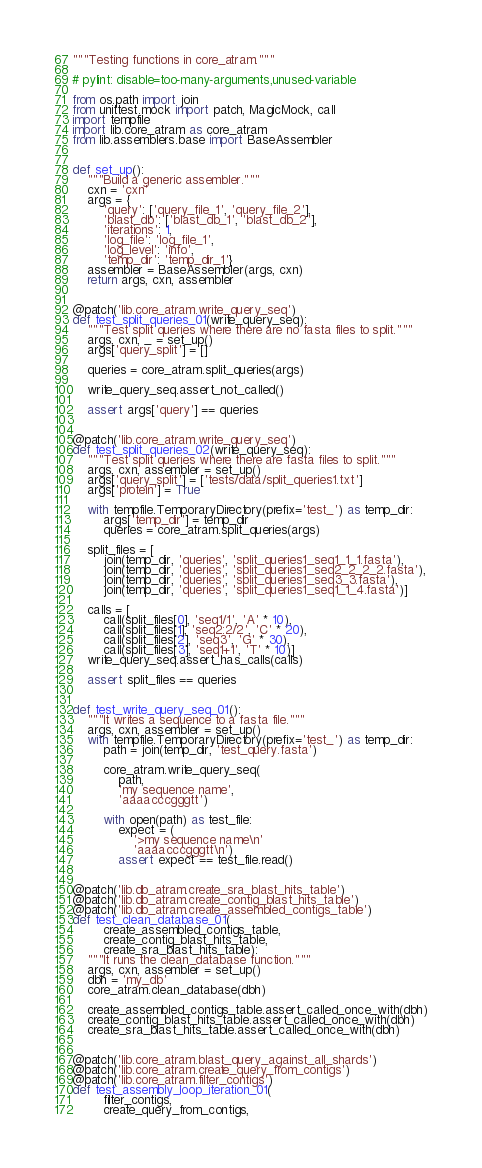<code> <loc_0><loc_0><loc_500><loc_500><_Python_>"""Testing functions in core_atram."""

# pylint: disable=too-many-arguments,unused-variable

from os.path import join
from unittest.mock import patch, MagicMock, call
import tempfile
import lib.core_atram as core_atram
from lib.assemblers.base import BaseAssembler


def set_up():
    """Build a generic assembler."""
    cxn = 'cxn'
    args = {
        'query': ['query_file_1', 'query_file_2'],
        'blast_db': ['blast_db_1', 'blast_db_2'],
        'iterations': 1,
        'log_file': 'log_file_1',
        'log_level': 'info',
        'temp_dir': 'temp_dir_1'}
    assembler = BaseAssembler(args, cxn)
    return args, cxn, assembler


@patch('lib.core_atram.write_query_seq')
def test_split_queries_01(write_query_seq):
    """Test split queries where there are no fasta files to split."""
    args, cxn, _ = set_up()
    args['query_split'] = []

    queries = core_atram.split_queries(args)

    write_query_seq.assert_not_called()

    assert args['query'] == queries


@patch('lib.core_atram.write_query_seq')
def test_split_queries_02(write_query_seq):
    """Test split queries where there are fasta files to split."""
    args, cxn, assembler = set_up()
    args['query_split'] = ['tests/data/split_queries1.txt']
    args['protein'] = True

    with tempfile.TemporaryDirectory(prefix='test_') as temp_dir:
        args['temp_dir'] = temp_dir
        queries = core_atram.split_queries(args)

    split_files = [
        join(temp_dir, 'queries', 'split_queries1_seq1_1_1.fasta'),
        join(temp_dir, 'queries', 'split_queries1_seq2_2_2_2.fasta'),
        join(temp_dir, 'queries', 'split_queries1_seq3_3.fasta'),
        join(temp_dir, 'queries', 'split_queries1_seq1_1_4.fasta')]

    calls = [
        call(split_files[0], 'seq1/1', 'A' * 10),
        call(split_files[1], 'seq2:2/2', 'C' * 20),
        call(split_files[2], 'seq3', 'G' * 30),
        call(split_files[3], 'seq1+1', 'T' * 10)]
    write_query_seq.assert_has_calls(calls)

    assert split_files == queries


def test_write_query_seq_01():
    """It writes a sequence to a fasta file."""
    args, cxn, assembler = set_up()
    with tempfile.TemporaryDirectory(prefix='test_') as temp_dir:
        path = join(temp_dir, 'test_query.fasta')

        core_atram.write_query_seq(
            path,
            'my sequence name',
            'aaaacccgggtt')

        with open(path) as test_file:
            expect = (
                '>my sequence name\n'
                'aaaacccgggtt\n')
            assert expect == test_file.read()


@patch('lib.db_atram.create_sra_blast_hits_table')
@patch('lib.db_atram.create_contig_blast_hits_table')
@patch('lib.db_atram.create_assembled_contigs_table')
def test_clean_database_01(
        create_assembled_contigs_table,
        create_contig_blast_hits_table,
        create_sra_blast_hits_table):
    """It runs the clean_database function."""
    args, cxn, assembler = set_up()
    dbh = 'my_db'
    core_atram.clean_database(dbh)

    create_assembled_contigs_table.assert_called_once_with(dbh)
    create_contig_blast_hits_table.assert_called_once_with(dbh)
    create_sra_blast_hits_table.assert_called_once_with(dbh)


@patch('lib.core_atram.blast_query_against_all_shards')
@patch('lib.core_atram.create_query_from_contigs')
@patch('lib.core_atram.filter_contigs')
def test_assembly_loop_iteration_01(
        filter_contigs,
        create_query_from_contigs,</code> 